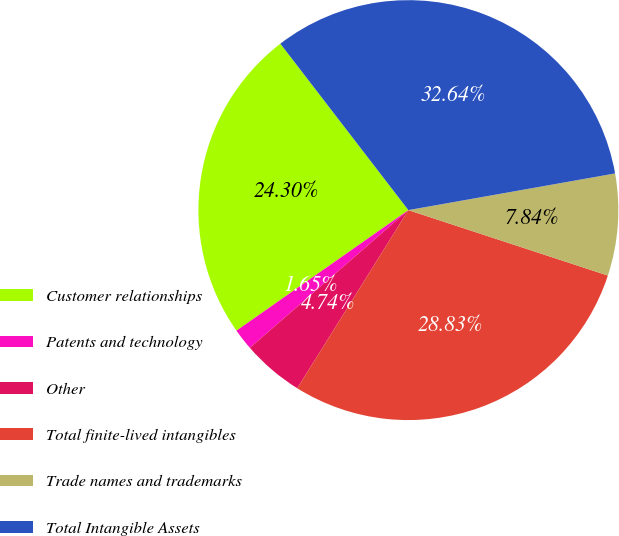Convert chart. <chart><loc_0><loc_0><loc_500><loc_500><pie_chart><fcel>Customer relationships<fcel>Patents and technology<fcel>Other<fcel>Total finite-lived intangibles<fcel>Trade names and trademarks<fcel>Total Intangible Assets<nl><fcel>24.3%<fcel>1.65%<fcel>4.74%<fcel>28.83%<fcel>7.84%<fcel>32.64%<nl></chart> 